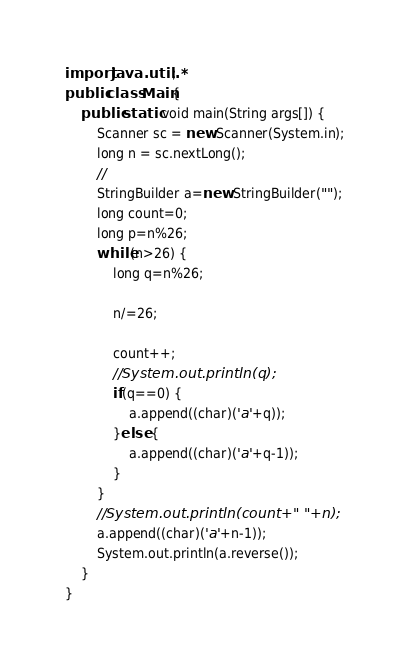Convert code to text. <code><loc_0><loc_0><loc_500><loc_500><_Java_>import java.util.*;
public class Main{
	public static void main(String args[]) {
		Scanner sc = new Scanner(System.in);
		long n = sc.nextLong();
		//
		StringBuilder a=new StringBuilder("");
		long count=0;
		long p=n%26;
		while(n>26) {
			long q=n%26;
			
			n/=26;
			
			count++;
			//System.out.println(q);
			if(q==0) {
				a.append((char)('a'+q));
			}else {
				a.append((char)('a'+q-1));
			}
		}
		//System.out.println(count+" "+n);
		a.append((char)('a'+n-1));
		System.out.println(a.reverse());
	}
}
</code> 